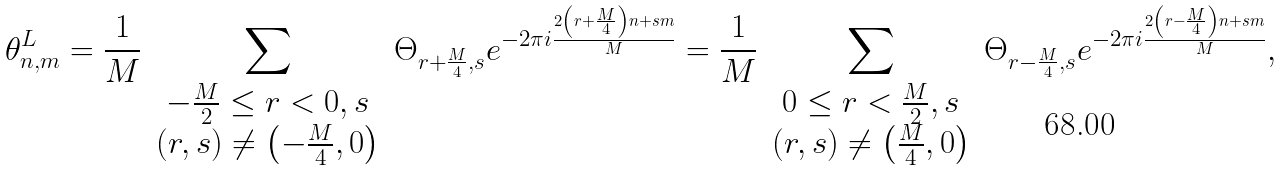<formula> <loc_0><loc_0><loc_500><loc_500>\theta _ { n , m } ^ { L } = \frac { 1 } { M } \sum _ { \begin{array} { c } - \frac { M } { 2 } \leq r < 0 , s \\ \left ( r , s \right ) \neq \left ( - \frac { M } { 4 } , 0 \right ) \end{array} } \Theta _ { r + \frac { M } { 4 } , s } e ^ { - 2 \pi i \frac { 2 \left ( r + \frac { M } { 4 } \right ) n + s m } { M } } = \frac { 1 } { M } \sum _ { \begin{array} { c } 0 \leq r < \frac { M } { 2 } , s \\ \left ( r , s \right ) \neq \left ( \frac { M } { 4 } , 0 \right ) \end{array} } \Theta _ { r - \frac { M } { 4 } , s } e ^ { - 2 \pi i \frac { 2 \left ( r - \frac { M } { 4 } \right ) n + s m } { M } } ,</formula> 